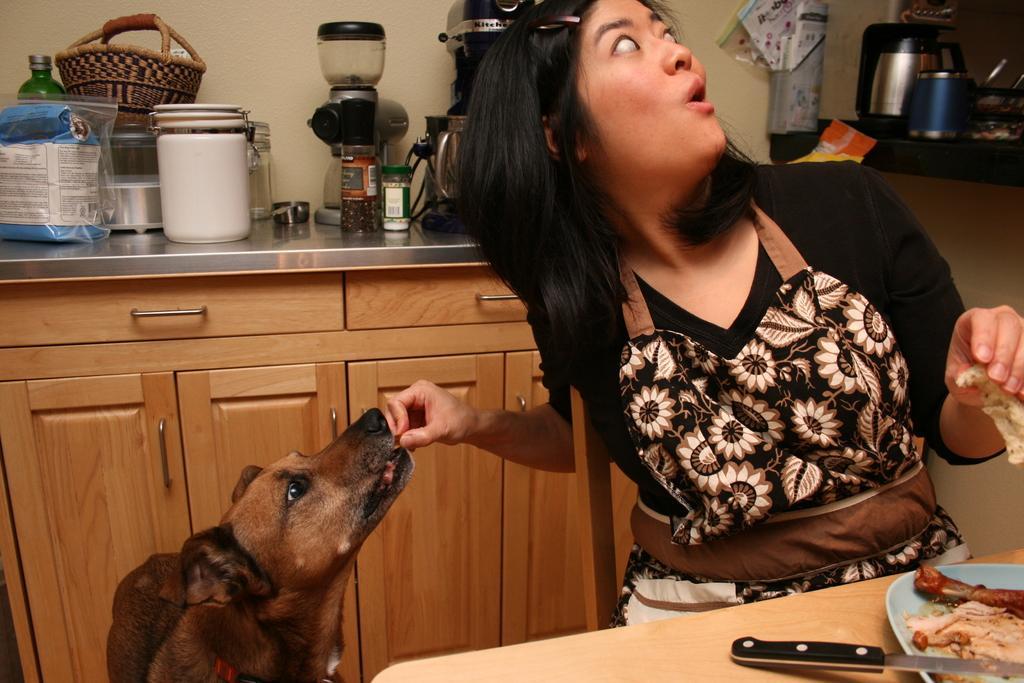Could you give a brief overview of what you see in this image? In this picture, we can see a lady feeding a dog and we can see the table with some objects on it like a plate with some food items, knife and we can see cupboards, and some objects on the surface like box, bag, basket and we can see some objects in the top right corner like coffee maker, glass and we can see the wall 